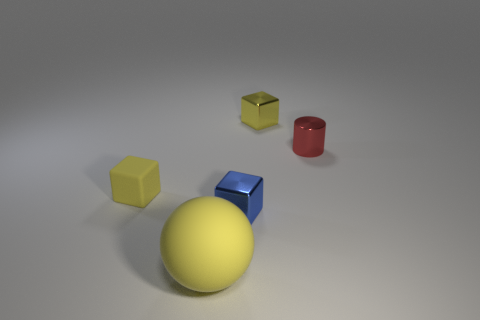There is a yellow matte object that is to the left of the yellow ball; is it the same size as the shiny thing that is in front of the tiny yellow matte cube? The yellow matte object to the left of the yellow ball does indeed appear to be similar in size to the red shiny cylinder positioned in front of the tiny yellow matte cube, though without precise measurements it's difficult to be certain. 